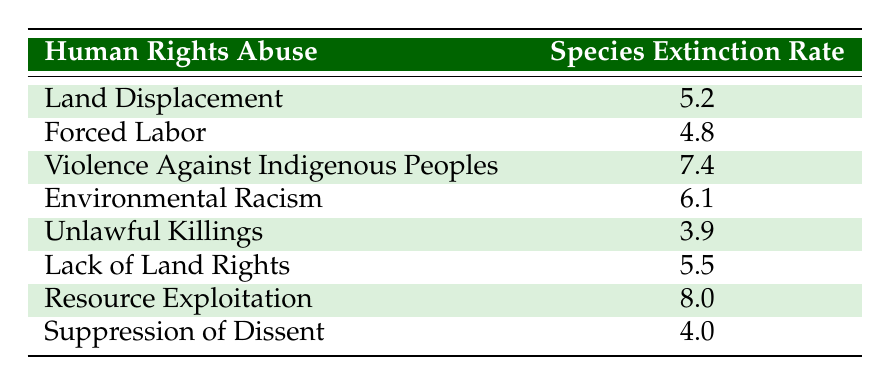What is the species extinction rate associated with environmental racism? The table lists environmental racism with a species extinction rate of 6.1.
Answer: 6.1 Which human rights abuse has the highest associated species extinction rate? By reviewing the table, resource exploitation has the highest extinction rate at 8.0.
Answer: Resource exploitation What is the average species extinction rate for land displacement and forced labor? The table shows land displacement at 5.2 and forced labor at 4.8. The average is (5.2 + 4.8) / 2 = 10 / 2 = 5.0.
Answer: 5.0 Is the species extinction rate for suppression of dissent higher than 4.0? The table shows suppression of dissent has a species extinction rate of 4.0, which is not higher than 4.0.
Answer: No What is the difference in species extinction rates between violence against indigenous peoples and unlawful killings? Violence against indigenous peoples has a rate of 7.4, while unlawful killings have a rate of 3.9. The difference is 7.4 - 3.9 = 3.5.
Answer: 3.5 Are there more human rights abuses with a species extinction rate above 6.0 or below 6.0? Checking the table, the values above 6.0 are violence against indigenous peoples (7.4), environmental racism (6.1), and resource exploitation (8.0), totaling 3 abuses. The values below 6.0 are land displacement (5.2), forced labor (4.8), unlawful killings (3.9), lack of land rights (5.5), and suppression of dissent (4.0), totaling 5 abuses. Thus, there are more below 6.0.
Answer: Below 6.0 What is the total species extinction rate for all human rights abuses listed? The species extinction rates are 5.2, 4.8, 7.4, 6.1, 3.9, 5.5, 8.0, and 4.0. Adding these together: 5.2 + 4.8 + 7.4 + 6.1 + 3.9 + 5.5 + 8.0 + 4.0 = 45.9.
Answer: 45.9 Which two human rights abuses have the lowest species extinction rates, and what is their average? The table shows unlawful killings at 3.9 and forced labor at 4.8 as the lowest rates. Their average is (3.9 + 4.8) / 2 = 8.7 / 2 = 4.35.
Answer: 4.35 